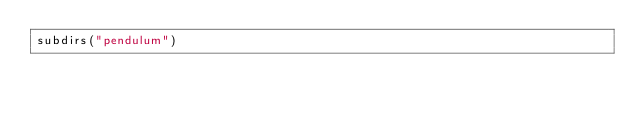<code> <loc_0><loc_0><loc_500><loc_500><_CMake_>subdirs("pendulum")
</code> 